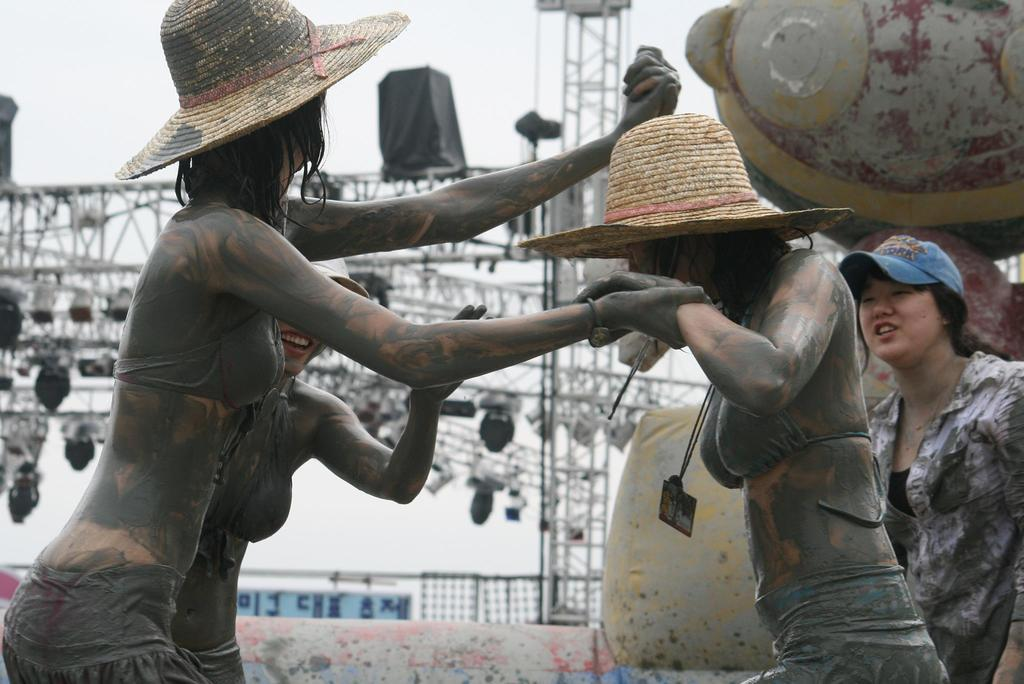What can be seen in the image? There are people standing in the image. What are the people wearing on their heads? All the people are wearing caps. What can be seen in the background of the image? There are metal rods and lights visible in the background. What type of substance is being used to build the crib in the image? There is no crib present in the image, so it is not possible to determine what type of substance is being used to build it. 